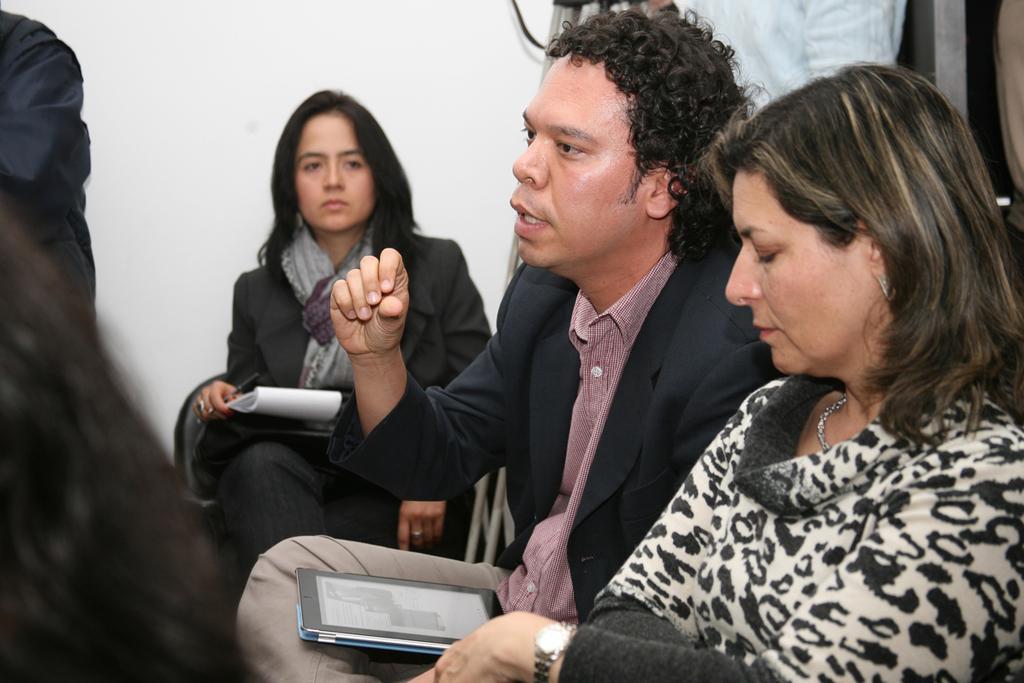How would you summarize this image in a sentence or two? This is the picture of a few people where we can see a woman sitting and holding an object and there is a person who is having an object in his lap. 